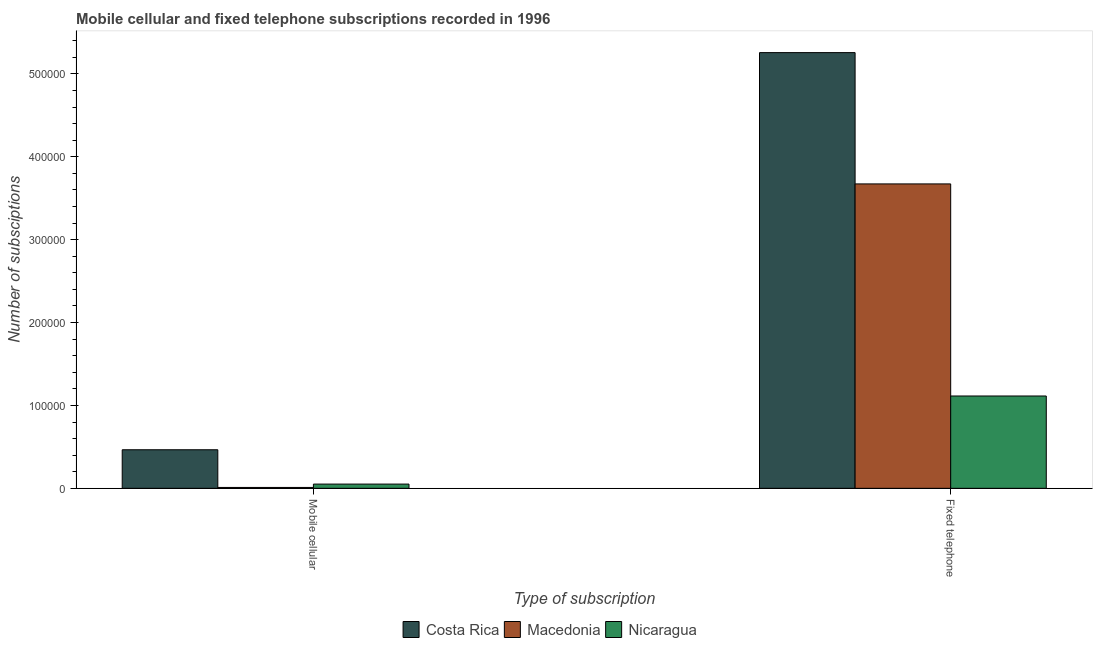How many groups of bars are there?
Make the answer very short. 2. Are the number of bars per tick equal to the number of legend labels?
Keep it short and to the point. Yes. Are the number of bars on each tick of the X-axis equal?
Provide a succinct answer. Yes. What is the label of the 2nd group of bars from the left?
Provide a succinct answer. Fixed telephone. What is the number of mobile cellular subscriptions in Costa Rica?
Provide a succinct answer. 4.65e+04. Across all countries, what is the maximum number of fixed telephone subscriptions?
Give a very brief answer. 5.26e+05. Across all countries, what is the minimum number of fixed telephone subscriptions?
Give a very brief answer. 1.11e+05. In which country was the number of fixed telephone subscriptions minimum?
Provide a short and direct response. Nicaragua. What is the total number of fixed telephone subscriptions in the graph?
Provide a succinct answer. 1.00e+06. What is the difference between the number of mobile cellular subscriptions in Nicaragua and that in Macedonia?
Your answer should be compact. 4042. What is the difference between the number of fixed telephone subscriptions in Nicaragua and the number of mobile cellular subscriptions in Macedonia?
Your response must be concise. 1.10e+05. What is the average number of mobile cellular subscriptions per country?
Make the answer very short. 1.76e+04. What is the difference between the number of fixed telephone subscriptions and number of mobile cellular subscriptions in Costa Rica?
Offer a terse response. 4.79e+05. What is the ratio of the number of mobile cellular subscriptions in Nicaragua to that in Macedonia?
Make the answer very short. 4.82. Is the number of fixed telephone subscriptions in Costa Rica less than that in Macedonia?
Your answer should be very brief. No. What does the 2nd bar from the left in Mobile cellular represents?
Your answer should be very brief. Macedonia. What does the 1st bar from the right in Fixed telephone represents?
Provide a succinct answer. Nicaragua. How many bars are there?
Offer a terse response. 6. Are all the bars in the graph horizontal?
Your response must be concise. No. What is the difference between two consecutive major ticks on the Y-axis?
Ensure brevity in your answer.  1.00e+05. Are the values on the major ticks of Y-axis written in scientific E-notation?
Your response must be concise. No. Does the graph contain any zero values?
Offer a terse response. No. Does the graph contain grids?
Offer a very short reply. No. Where does the legend appear in the graph?
Offer a terse response. Bottom center. How many legend labels are there?
Offer a very short reply. 3. How are the legend labels stacked?
Your response must be concise. Horizontal. What is the title of the graph?
Offer a terse response. Mobile cellular and fixed telephone subscriptions recorded in 1996. Does "Belgium" appear as one of the legend labels in the graph?
Offer a terse response. No. What is the label or title of the X-axis?
Offer a terse response. Type of subscription. What is the label or title of the Y-axis?
Give a very brief answer. Number of subsciptions. What is the Number of subsciptions in Costa Rica in Mobile cellular?
Your answer should be compact. 4.65e+04. What is the Number of subsciptions in Macedonia in Mobile cellular?
Provide a short and direct response. 1058. What is the Number of subsciptions of Nicaragua in Mobile cellular?
Keep it short and to the point. 5100. What is the Number of subsciptions of Costa Rica in Fixed telephone?
Give a very brief answer. 5.26e+05. What is the Number of subsciptions in Macedonia in Fixed telephone?
Your answer should be very brief. 3.67e+05. What is the Number of subsciptions in Nicaragua in Fixed telephone?
Ensure brevity in your answer.  1.11e+05. Across all Type of subscription, what is the maximum Number of subsciptions in Costa Rica?
Keep it short and to the point. 5.26e+05. Across all Type of subscription, what is the maximum Number of subsciptions of Macedonia?
Offer a very short reply. 3.67e+05. Across all Type of subscription, what is the maximum Number of subsciptions in Nicaragua?
Ensure brevity in your answer.  1.11e+05. Across all Type of subscription, what is the minimum Number of subsciptions of Costa Rica?
Give a very brief answer. 4.65e+04. Across all Type of subscription, what is the minimum Number of subsciptions in Macedonia?
Provide a short and direct response. 1058. Across all Type of subscription, what is the minimum Number of subsciptions of Nicaragua?
Make the answer very short. 5100. What is the total Number of subsciptions of Costa Rica in the graph?
Keep it short and to the point. 5.72e+05. What is the total Number of subsciptions of Macedonia in the graph?
Ensure brevity in your answer.  3.68e+05. What is the total Number of subsciptions in Nicaragua in the graph?
Make the answer very short. 1.16e+05. What is the difference between the Number of subsciptions of Costa Rica in Mobile cellular and that in Fixed telephone?
Your answer should be very brief. -4.79e+05. What is the difference between the Number of subsciptions of Macedonia in Mobile cellular and that in Fixed telephone?
Offer a terse response. -3.66e+05. What is the difference between the Number of subsciptions in Nicaragua in Mobile cellular and that in Fixed telephone?
Offer a terse response. -1.06e+05. What is the difference between the Number of subsciptions of Costa Rica in Mobile cellular and the Number of subsciptions of Macedonia in Fixed telephone?
Provide a short and direct response. -3.21e+05. What is the difference between the Number of subsciptions of Costa Rica in Mobile cellular and the Number of subsciptions of Nicaragua in Fixed telephone?
Offer a very short reply. -6.49e+04. What is the difference between the Number of subsciptions of Macedonia in Mobile cellular and the Number of subsciptions of Nicaragua in Fixed telephone?
Your answer should be compact. -1.10e+05. What is the average Number of subsciptions in Costa Rica per Type of subscription?
Ensure brevity in your answer.  2.86e+05. What is the average Number of subsciptions in Macedonia per Type of subscription?
Your response must be concise. 1.84e+05. What is the average Number of subsciptions of Nicaragua per Type of subscription?
Offer a terse response. 5.82e+04. What is the difference between the Number of subsciptions in Costa Rica and Number of subsciptions in Macedonia in Mobile cellular?
Your response must be concise. 4.55e+04. What is the difference between the Number of subsciptions of Costa Rica and Number of subsciptions of Nicaragua in Mobile cellular?
Ensure brevity in your answer.  4.14e+04. What is the difference between the Number of subsciptions of Macedonia and Number of subsciptions of Nicaragua in Mobile cellular?
Offer a very short reply. -4042. What is the difference between the Number of subsciptions of Costa Rica and Number of subsciptions of Macedonia in Fixed telephone?
Keep it short and to the point. 1.58e+05. What is the difference between the Number of subsciptions of Costa Rica and Number of subsciptions of Nicaragua in Fixed telephone?
Provide a succinct answer. 4.14e+05. What is the difference between the Number of subsciptions in Macedonia and Number of subsciptions in Nicaragua in Fixed telephone?
Provide a short and direct response. 2.56e+05. What is the ratio of the Number of subsciptions in Costa Rica in Mobile cellular to that in Fixed telephone?
Your answer should be very brief. 0.09. What is the ratio of the Number of subsciptions in Macedonia in Mobile cellular to that in Fixed telephone?
Your response must be concise. 0. What is the ratio of the Number of subsciptions in Nicaragua in Mobile cellular to that in Fixed telephone?
Your answer should be very brief. 0.05. What is the difference between the highest and the second highest Number of subsciptions in Costa Rica?
Your response must be concise. 4.79e+05. What is the difference between the highest and the second highest Number of subsciptions of Macedonia?
Give a very brief answer. 3.66e+05. What is the difference between the highest and the second highest Number of subsciptions of Nicaragua?
Provide a succinct answer. 1.06e+05. What is the difference between the highest and the lowest Number of subsciptions in Costa Rica?
Give a very brief answer. 4.79e+05. What is the difference between the highest and the lowest Number of subsciptions of Macedonia?
Give a very brief answer. 3.66e+05. What is the difference between the highest and the lowest Number of subsciptions of Nicaragua?
Make the answer very short. 1.06e+05. 